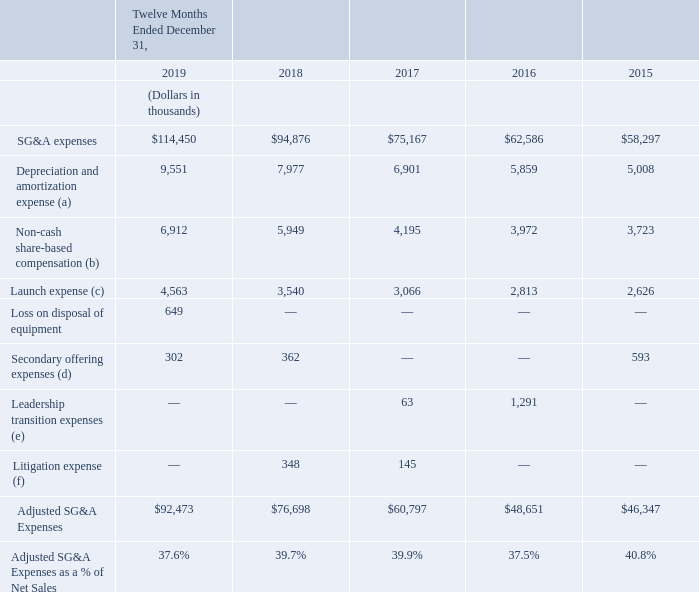The following table provides a reconciliation of Adjusted SG&A to SG&A expenses, the most directly comparable financial measure presented in accordance with U.S. GAAP:
(a) Represents depreciation and amortization expense included in SG&A.
(b) Represents non-cash share-based compensation expense included in SG&A.
(c) Represents new store marketing allowance of $1,000 for each store added to our distribution network, as well as the non-capitalized freight costs associated with Freshpet Fridge replacements. The expense enhances the overall marketing spend to support our growing distribution network.
(d) Represents fees associated with secondary public offerings of our common stock.
(e) Represents charges associated with our former Chief Executive Officer’s separation agreement, as well as changes in estimates associated with leadership transition costs
(f) Represents fees associated with two securities lawsuits.
What does launch expense represent? New store marketing allowance of $1,000 for each store added to our distribution network, as well as the non-capitalized freight costs associated with freshpet fridge replacements. What does secondary offering expenses represent? Fees associated with secondary public offerings of our common stock. What does Leadership transition expenses represent? Charges associated with our former chief executive officer’s separation agreement, as well as changes in estimates associated with leadership transition costs. Which year had the greatest SG&A expenses? $114,450>$94,876>$75,167>$62,586>$58,297
Answer: 2019. Which year had the greatest adjusted SG&A expenses? $92,473>$76,698>$60,797>$48,651>$46,347
Answer: 2019. How many types of expenses are listed in the table? SG&A expenses## Depreciation and amortization expense## Non-cash share-based compensation## Launch expense## Loss on disposal of equipment ## Secondary offering expenses## Leadership transition expenses ## Litigation expense
Answer: 8. 